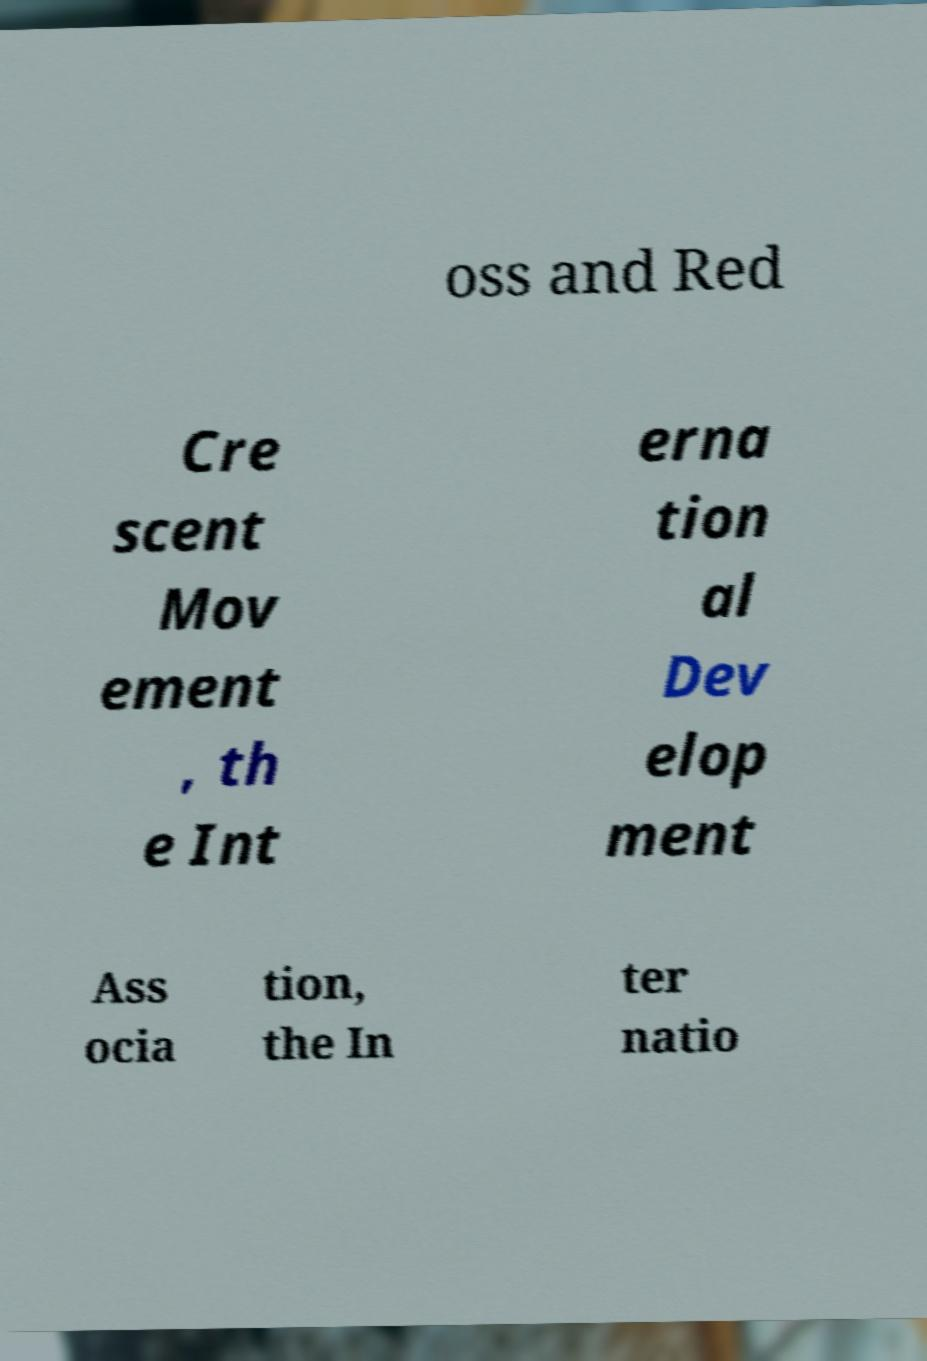Please identify and transcribe the text found in this image. oss and Red Cre scent Mov ement , th e Int erna tion al Dev elop ment Ass ocia tion, the In ter natio 